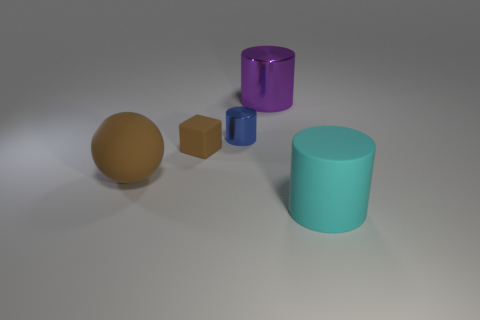Do the large ball and the small rubber thing have the same color?
Provide a short and direct response. Yes. Is there any other thing that has the same shape as the small brown object?
Provide a succinct answer. No. Are there any tiny brown matte objects?
Keep it short and to the point. Yes. Is there a cylinder behind the tiny brown matte cube to the left of the large object that is behind the blue cylinder?
Make the answer very short. Yes. Does the blue thing have the same shape as the matte thing that is to the right of the large purple shiny cylinder?
Keep it short and to the point. Yes. What is the color of the big cylinder on the left side of the big matte object on the right side of the tiny thing left of the blue thing?
Offer a very short reply. Purple. How many objects are either large objects on the left side of the big rubber cylinder or cylinders that are on the left side of the purple metal thing?
Provide a short and direct response. 3. What number of other objects are there of the same color as the big metallic cylinder?
Provide a succinct answer. 0. There is a shiny thing that is left of the big purple cylinder; does it have the same shape as the cyan thing?
Offer a terse response. Yes. Are there fewer tiny blue cylinders to the left of the blue thing than large purple things?
Keep it short and to the point. Yes. 